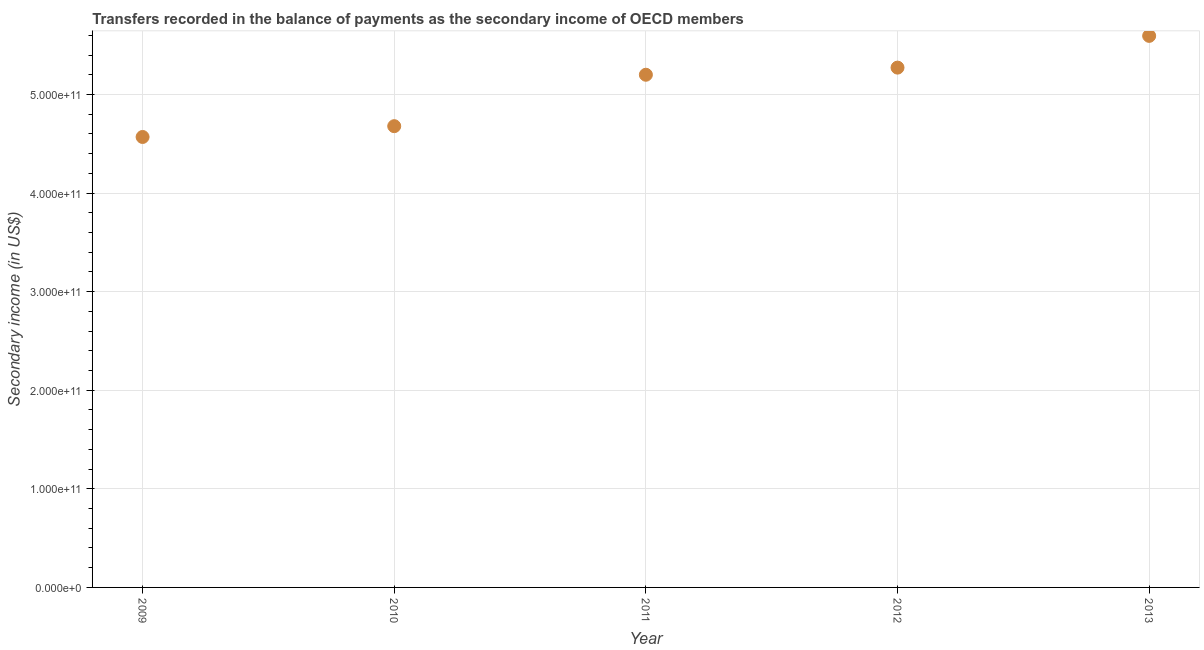What is the amount of secondary income in 2011?
Keep it short and to the point. 5.20e+11. Across all years, what is the maximum amount of secondary income?
Offer a terse response. 5.59e+11. Across all years, what is the minimum amount of secondary income?
Your response must be concise. 4.57e+11. What is the sum of the amount of secondary income?
Offer a terse response. 2.53e+12. What is the difference between the amount of secondary income in 2010 and 2013?
Provide a succinct answer. -9.16e+1. What is the average amount of secondary income per year?
Provide a short and direct response. 5.06e+11. What is the median amount of secondary income?
Offer a terse response. 5.20e+11. In how many years, is the amount of secondary income greater than 80000000000 US$?
Your answer should be compact. 5. What is the ratio of the amount of secondary income in 2010 to that in 2013?
Your answer should be very brief. 0.84. Is the amount of secondary income in 2010 less than that in 2012?
Your response must be concise. Yes. What is the difference between the highest and the second highest amount of secondary income?
Provide a short and direct response. 3.22e+1. What is the difference between the highest and the lowest amount of secondary income?
Provide a short and direct response. 1.03e+11. In how many years, is the amount of secondary income greater than the average amount of secondary income taken over all years?
Offer a very short reply. 3. How many dotlines are there?
Give a very brief answer. 1. What is the difference between two consecutive major ticks on the Y-axis?
Your answer should be very brief. 1.00e+11. Are the values on the major ticks of Y-axis written in scientific E-notation?
Your answer should be compact. Yes. What is the title of the graph?
Your answer should be compact. Transfers recorded in the balance of payments as the secondary income of OECD members. What is the label or title of the X-axis?
Provide a succinct answer. Year. What is the label or title of the Y-axis?
Your answer should be very brief. Secondary income (in US$). What is the Secondary income (in US$) in 2009?
Provide a short and direct response. 4.57e+11. What is the Secondary income (in US$) in 2010?
Ensure brevity in your answer.  4.68e+11. What is the Secondary income (in US$) in 2011?
Give a very brief answer. 5.20e+11. What is the Secondary income (in US$) in 2012?
Give a very brief answer. 5.27e+11. What is the Secondary income (in US$) in 2013?
Provide a succinct answer. 5.59e+11. What is the difference between the Secondary income (in US$) in 2009 and 2010?
Ensure brevity in your answer.  -1.10e+1. What is the difference between the Secondary income (in US$) in 2009 and 2011?
Provide a short and direct response. -6.31e+1. What is the difference between the Secondary income (in US$) in 2009 and 2012?
Give a very brief answer. -7.03e+1. What is the difference between the Secondary income (in US$) in 2009 and 2013?
Make the answer very short. -1.03e+11. What is the difference between the Secondary income (in US$) in 2010 and 2011?
Your answer should be compact. -5.22e+1. What is the difference between the Secondary income (in US$) in 2010 and 2012?
Ensure brevity in your answer.  -5.94e+1. What is the difference between the Secondary income (in US$) in 2010 and 2013?
Your answer should be very brief. -9.16e+1. What is the difference between the Secondary income (in US$) in 2011 and 2012?
Provide a succinct answer. -7.23e+09. What is the difference between the Secondary income (in US$) in 2011 and 2013?
Provide a succinct answer. -3.94e+1. What is the difference between the Secondary income (in US$) in 2012 and 2013?
Offer a terse response. -3.22e+1. What is the ratio of the Secondary income (in US$) in 2009 to that in 2011?
Your answer should be compact. 0.88. What is the ratio of the Secondary income (in US$) in 2009 to that in 2012?
Your response must be concise. 0.87. What is the ratio of the Secondary income (in US$) in 2009 to that in 2013?
Your response must be concise. 0.82. What is the ratio of the Secondary income (in US$) in 2010 to that in 2011?
Provide a short and direct response. 0.9. What is the ratio of the Secondary income (in US$) in 2010 to that in 2012?
Make the answer very short. 0.89. What is the ratio of the Secondary income (in US$) in 2010 to that in 2013?
Keep it short and to the point. 0.84. What is the ratio of the Secondary income (in US$) in 2012 to that in 2013?
Provide a succinct answer. 0.94. 